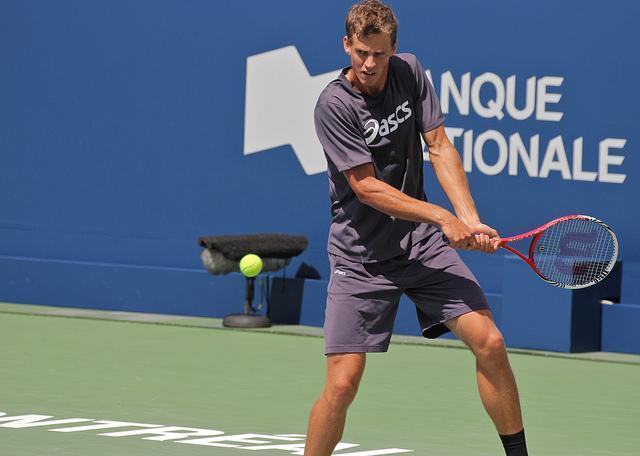How many white boats are to the side of the building?
Give a very brief answer. 0. 